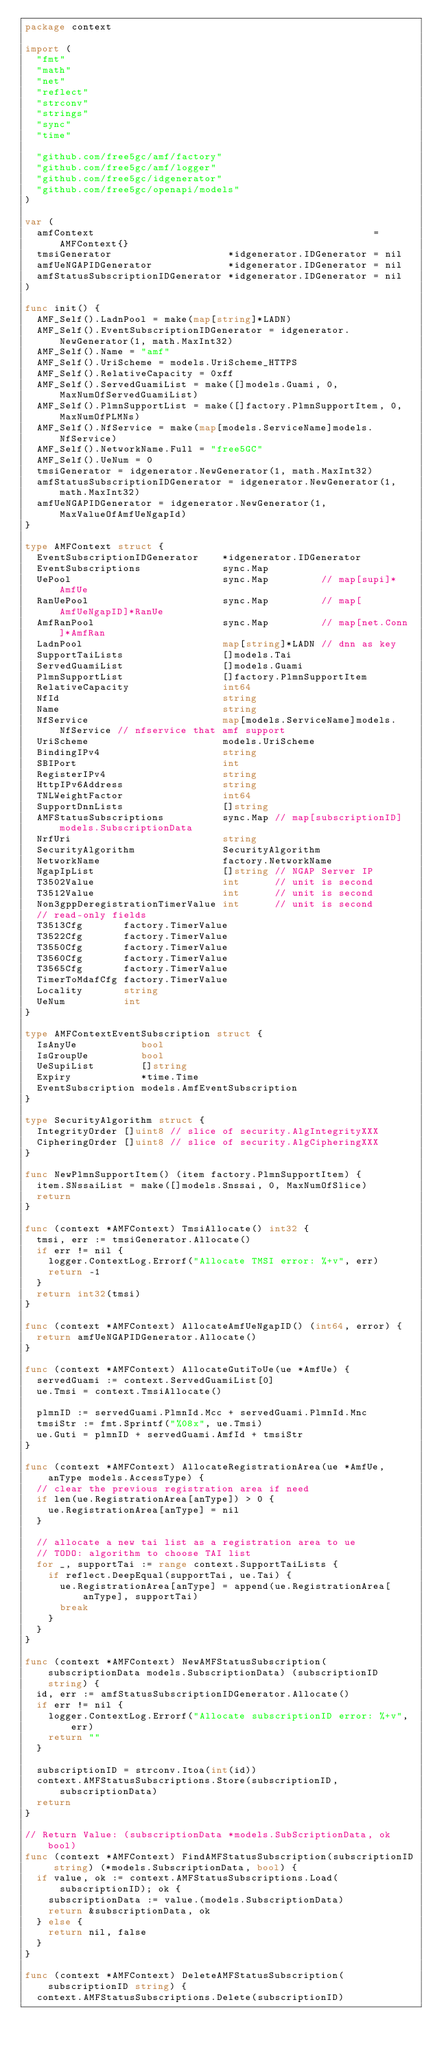Convert code to text. <code><loc_0><loc_0><loc_500><loc_500><_Go_>package context

import (
	"fmt"
	"math"
	"net"
	"reflect"
	"strconv"
	"strings"
	"sync"
	"time"

	"github.com/free5gc/amf/factory"
	"github.com/free5gc/amf/logger"
	"github.com/free5gc/idgenerator"
	"github.com/free5gc/openapi/models"
)

var (
	amfContext                                                = AMFContext{}
	tmsiGenerator                    *idgenerator.IDGenerator = nil
	amfUeNGAPIDGenerator             *idgenerator.IDGenerator = nil
	amfStatusSubscriptionIDGenerator *idgenerator.IDGenerator = nil
)

func init() {
	AMF_Self().LadnPool = make(map[string]*LADN)
	AMF_Self().EventSubscriptionIDGenerator = idgenerator.NewGenerator(1, math.MaxInt32)
	AMF_Self().Name = "amf"
	AMF_Self().UriScheme = models.UriScheme_HTTPS
	AMF_Self().RelativeCapacity = 0xff
	AMF_Self().ServedGuamiList = make([]models.Guami, 0, MaxNumOfServedGuamiList)
	AMF_Self().PlmnSupportList = make([]factory.PlmnSupportItem, 0, MaxNumOfPLMNs)
	AMF_Self().NfService = make(map[models.ServiceName]models.NfService)
	AMF_Self().NetworkName.Full = "free5GC"
	AMF_Self().UeNum = 0
	tmsiGenerator = idgenerator.NewGenerator(1, math.MaxInt32)
	amfStatusSubscriptionIDGenerator = idgenerator.NewGenerator(1, math.MaxInt32)
	amfUeNGAPIDGenerator = idgenerator.NewGenerator(1, MaxValueOfAmfUeNgapId)
}

type AMFContext struct {
	EventSubscriptionIDGenerator    *idgenerator.IDGenerator
	EventSubscriptions              sync.Map
	UePool                          sync.Map         // map[supi]*AmfUe
	RanUePool                       sync.Map         // map[AmfUeNgapID]*RanUe
	AmfRanPool                      sync.Map         // map[net.Conn]*AmfRan
	LadnPool                        map[string]*LADN // dnn as key
	SupportTaiLists                 []models.Tai
	ServedGuamiList                 []models.Guami
	PlmnSupportList                 []factory.PlmnSupportItem
	RelativeCapacity                int64
	NfId                            string
	Name                            string
	NfService                       map[models.ServiceName]models.NfService // nfservice that amf support
	UriScheme                       models.UriScheme
	BindingIPv4                     string
	SBIPort                         int
	RegisterIPv4                    string
	HttpIPv6Address                 string
	TNLWeightFactor                 int64
	SupportDnnLists                 []string
	AMFStatusSubscriptions          sync.Map // map[subscriptionID]models.SubscriptionData
	NrfUri                          string
	SecurityAlgorithm               SecurityAlgorithm
	NetworkName                     factory.NetworkName
	NgapIpList                      []string // NGAP Server IP
	T3502Value                      int      // unit is second
	T3512Value                      int      // unit is second
	Non3gppDeregistrationTimerValue int      // unit is second
	// read-only fields
	T3513Cfg       factory.TimerValue
	T3522Cfg       factory.TimerValue
	T3550Cfg       factory.TimerValue
	T3560Cfg       factory.TimerValue
	T3565Cfg       factory.TimerValue
	TimerToMdafCfg factory.TimerValue
	Locality       string
	UeNum          int
}

type AMFContextEventSubscription struct {
	IsAnyUe           bool
	IsGroupUe         bool
	UeSupiList        []string
	Expiry            *time.Time
	EventSubscription models.AmfEventSubscription
}

type SecurityAlgorithm struct {
	IntegrityOrder []uint8 // slice of security.AlgIntegrityXXX
	CipheringOrder []uint8 // slice of security.AlgCipheringXXX
}

func NewPlmnSupportItem() (item factory.PlmnSupportItem) {
	item.SNssaiList = make([]models.Snssai, 0, MaxNumOfSlice)
	return
}

func (context *AMFContext) TmsiAllocate() int32 {
	tmsi, err := tmsiGenerator.Allocate()
	if err != nil {
		logger.ContextLog.Errorf("Allocate TMSI error: %+v", err)
		return -1
	}
	return int32(tmsi)
}

func (context *AMFContext) AllocateAmfUeNgapID() (int64, error) {
	return amfUeNGAPIDGenerator.Allocate()
}

func (context *AMFContext) AllocateGutiToUe(ue *AmfUe) {
	servedGuami := context.ServedGuamiList[0]
	ue.Tmsi = context.TmsiAllocate()

	plmnID := servedGuami.PlmnId.Mcc + servedGuami.PlmnId.Mnc
	tmsiStr := fmt.Sprintf("%08x", ue.Tmsi)
	ue.Guti = plmnID + servedGuami.AmfId + tmsiStr
}

func (context *AMFContext) AllocateRegistrationArea(ue *AmfUe, anType models.AccessType) {
	// clear the previous registration area if need
	if len(ue.RegistrationArea[anType]) > 0 {
		ue.RegistrationArea[anType] = nil
	}

	// allocate a new tai list as a registration area to ue
	// TODO: algorithm to choose TAI list
	for _, supportTai := range context.SupportTaiLists {
		if reflect.DeepEqual(supportTai, ue.Tai) {
			ue.RegistrationArea[anType] = append(ue.RegistrationArea[anType], supportTai)
			break
		}
	}
}

func (context *AMFContext) NewAMFStatusSubscription(subscriptionData models.SubscriptionData) (subscriptionID string) {
	id, err := amfStatusSubscriptionIDGenerator.Allocate()
	if err != nil {
		logger.ContextLog.Errorf("Allocate subscriptionID error: %+v", err)
		return ""
	}

	subscriptionID = strconv.Itoa(int(id))
	context.AMFStatusSubscriptions.Store(subscriptionID, subscriptionData)
	return
}

// Return Value: (subscriptionData *models.SubScriptionData, ok bool)
func (context *AMFContext) FindAMFStatusSubscription(subscriptionID string) (*models.SubscriptionData, bool) {
	if value, ok := context.AMFStatusSubscriptions.Load(subscriptionID); ok {
		subscriptionData := value.(models.SubscriptionData)
		return &subscriptionData, ok
	} else {
		return nil, false
	}
}

func (context *AMFContext) DeleteAMFStatusSubscription(subscriptionID string) {
	context.AMFStatusSubscriptions.Delete(subscriptionID)</code> 